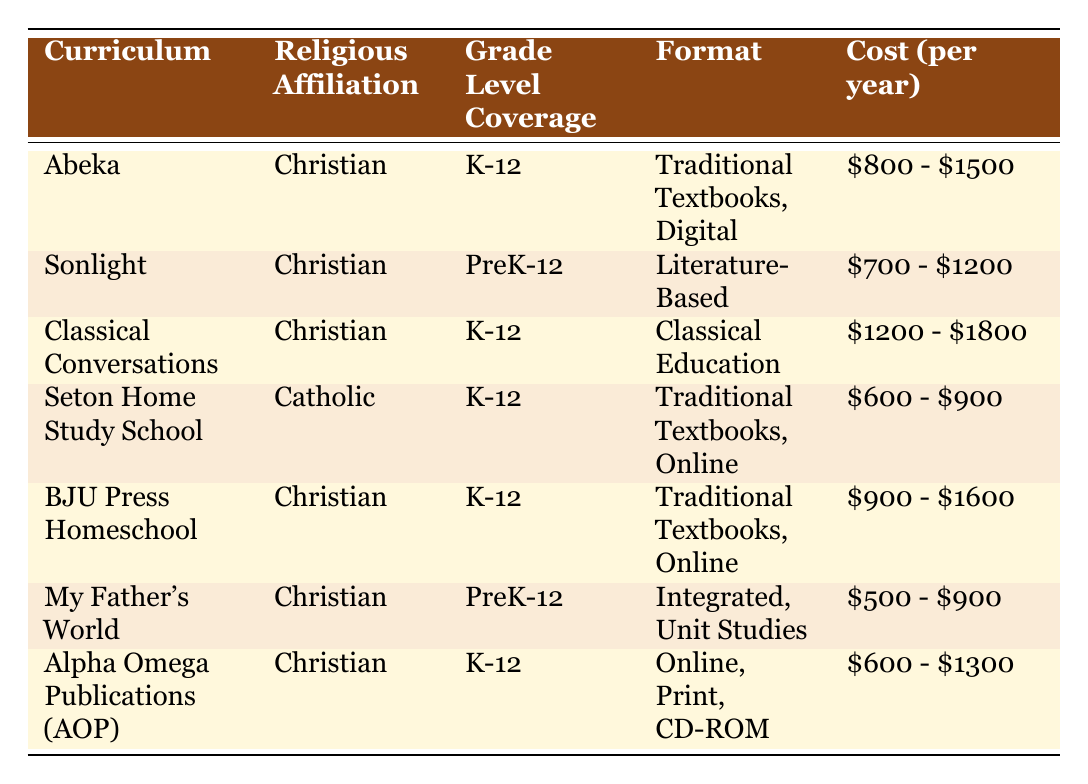What is the cost range for the Abeka curriculum? The cost range for the Abeka curriculum is listed in the "Cost (per year)" column of the table, which shows "$800 - $1500."
Answer: $800 - $1500 How many curriculums have a "Christian" religious affiliation? By scanning the "Religious Affiliation" column, we can see that 6 out of the 7 curricula listed are affiliated with Christianity (Abeka, Sonlight, Classical Conversations, BJU Press Homeschool, My Father's World, Alpha Omega Publications).
Answer: 6 Which curriculum offers the lowest cost range and what is that cost range? Checking the "Cost (per year)" for each curriculum, "My Father's World" has the lowest range of "$500 - $900," which is the minimum among all listed.
Answer: $500 - $900 Is Seton Home Study School accredited? From the "Accreditation" column, Seton Home Study School is listed with "Yes," indicating that it is accredited.
Answer: Yes What is the average cost of the curriculums in the table? To find the average cost, we take the mean of the midpoints of each cost range. First, we calculate the midpoints: for Abeka it's ($800+$1500)/2 = $1150, Sonlight is $950, Classical Conversations is $1500, Seton is $750, BJU Press is $1250, My Father's World is $700, and AOP is $950. Adding these midpoints together gives $1150 + $950 + $1500 + $750 + $1250 + $700 + $950 = $8250. Dividing by 7 (the number of curricula) results in $8250 / 7 = approximately $1178.57.
Answer: $1178.57 Which curriculum covers grades PreK-12 and has the highest cost range? From the table, we check the "Grade Level Coverage" column for "PreK-12" which identifies Sonlight and My Father's World. Among these, Sonlight has a cost range of "$700 - $1200," while My Father's World has a range of "$500 - $900," which indicates that Sonlight is the one with the highest cost.
Answer: Sonlight How many of the curriculums provide extensive teacher support? By reviewing the "Teacher Support" column, we see that Abeka, Classical Conversations, Seton Home Study School, BJU Press Homeschool, and Alpha Omega Publications all indicate "Extensive." Counting these gives us 5 curricula with extensive teacher support.
Answer: 5 Is there any curriculum in the table that follows a "Literature-Based" format? Looking through the "Format" column, we find that Sonlight is the only curriculum listed as "Literature-Based."
Answer: Yes 